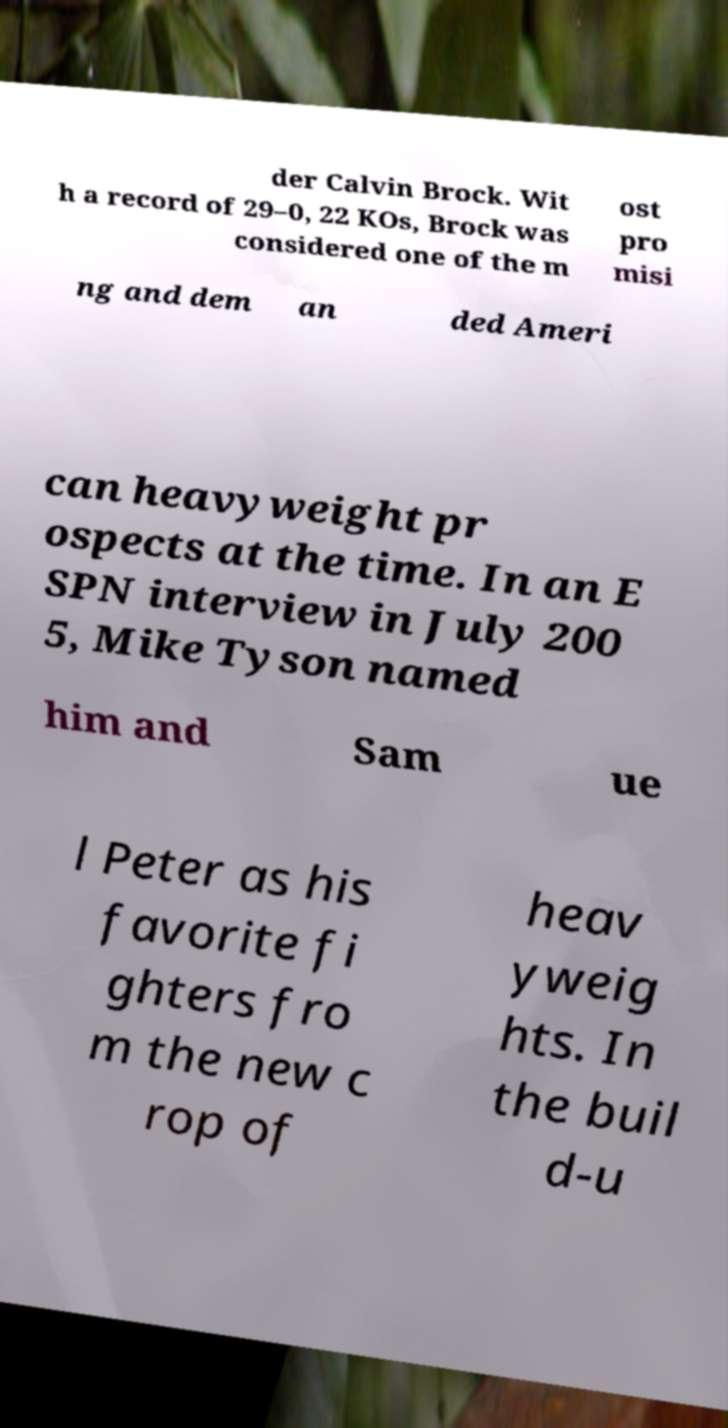Can you read and provide the text displayed in the image?This photo seems to have some interesting text. Can you extract and type it out for me? der Calvin Brock. Wit h a record of 29–0, 22 KOs, Brock was considered one of the m ost pro misi ng and dem an ded Ameri can heavyweight pr ospects at the time. In an E SPN interview in July 200 5, Mike Tyson named him and Sam ue l Peter as his favorite fi ghters fro m the new c rop of heav yweig hts. In the buil d-u 